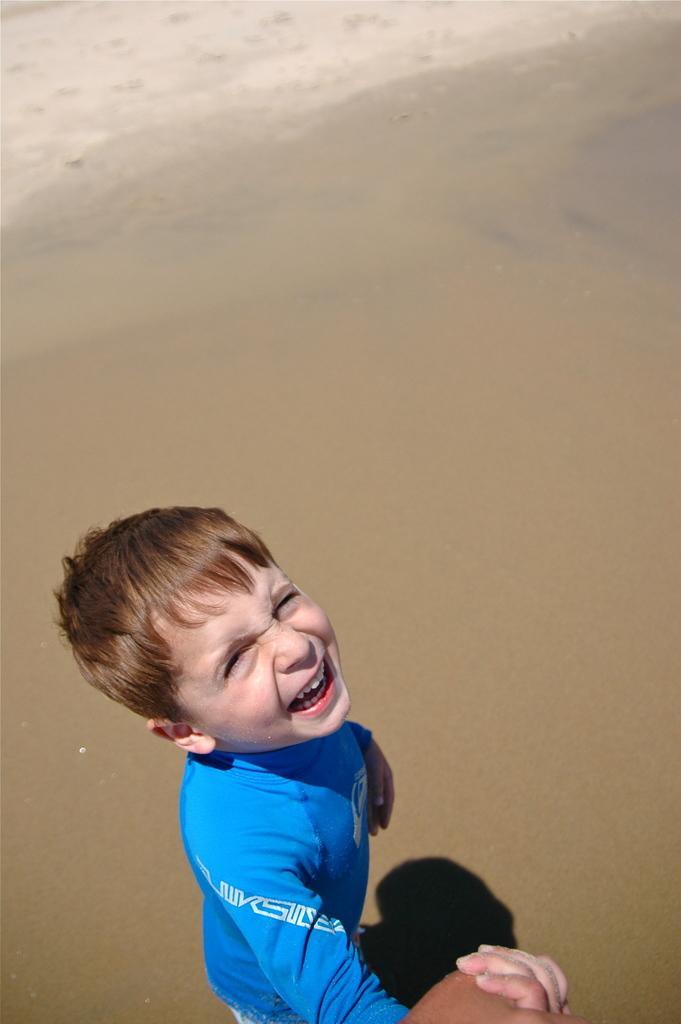Could you give a brief overview of what you see in this image? In the image there is a boy in blue t-shirt walking on the sand. 